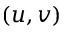<formula> <loc_0><loc_0><loc_500><loc_500>( u , v )</formula> 